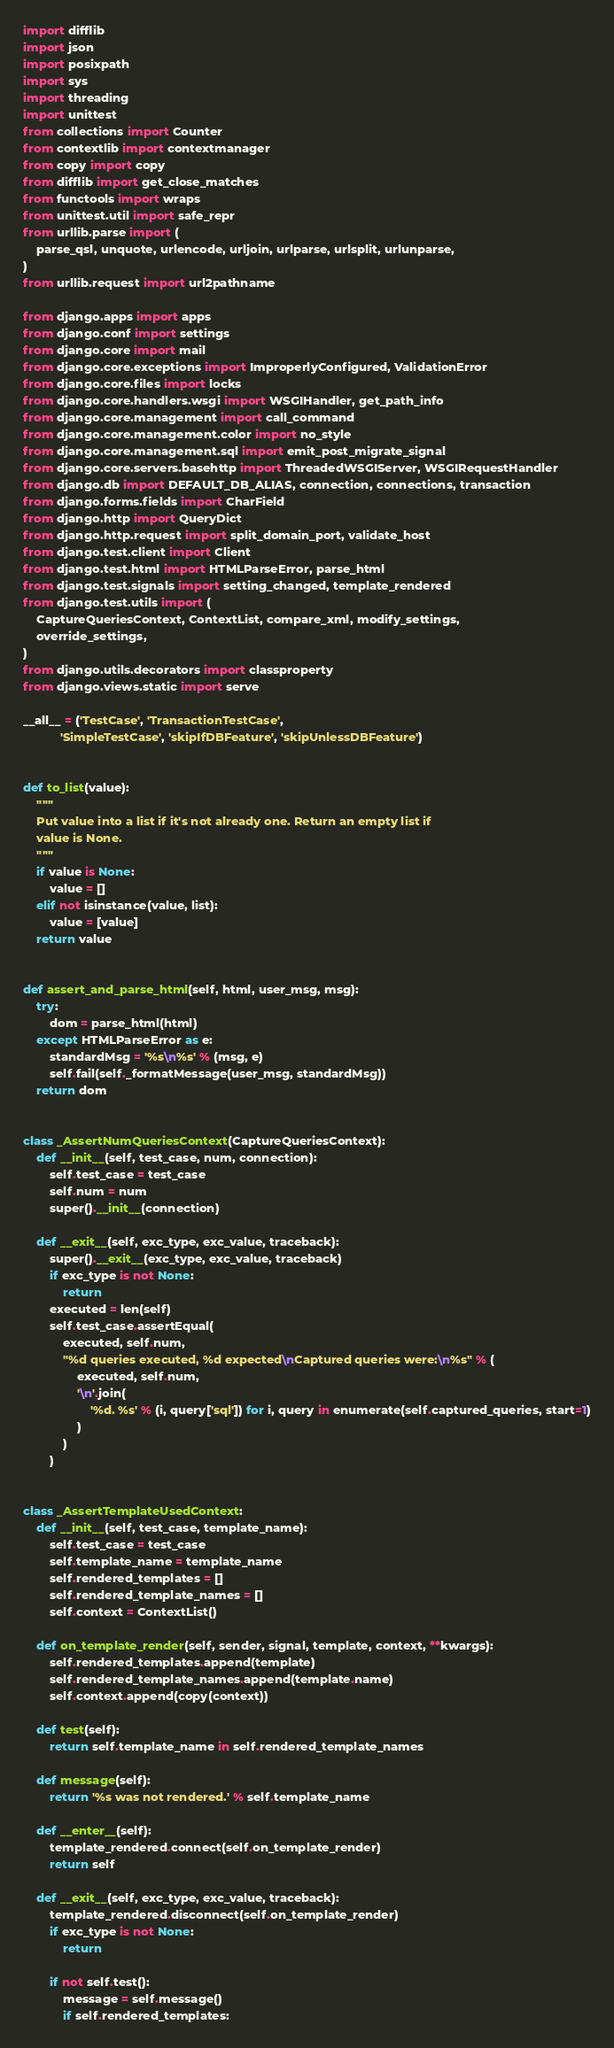<code> <loc_0><loc_0><loc_500><loc_500><_Python_>import difflib
import json
import posixpath
import sys
import threading
import unittest
from collections import Counter
from contextlib import contextmanager
from copy import copy
from difflib import get_close_matches
from functools import wraps
from unittest.util import safe_repr
from urllib.parse import (
    parse_qsl, unquote, urlencode, urljoin, urlparse, urlsplit, urlunparse,
)
from urllib.request import url2pathname

from django.apps import apps
from django.conf import settings
from django.core import mail
from django.core.exceptions import ImproperlyConfigured, ValidationError
from django.core.files import locks
from django.core.handlers.wsgi import WSGIHandler, get_path_info
from django.core.management import call_command
from django.core.management.color import no_style
from django.core.management.sql import emit_post_migrate_signal
from django.core.servers.basehttp import ThreadedWSGIServer, WSGIRequestHandler
from django.db import DEFAULT_DB_ALIAS, connection, connections, transaction
from django.forms.fields import CharField
from django.http import QueryDict
from django.http.request import split_domain_port, validate_host
from django.test.client import Client
from django.test.html import HTMLParseError, parse_html
from django.test.signals import setting_changed, template_rendered
from django.test.utils import (
    CaptureQueriesContext, ContextList, compare_xml, modify_settings,
    override_settings,
)
from django.utils.decorators import classproperty
from django.views.static import serve

__all__ = ('TestCase', 'TransactionTestCase',
           'SimpleTestCase', 'skipIfDBFeature', 'skipUnlessDBFeature')


def to_list(value):
    """
    Put value into a list if it's not already one. Return an empty list if
    value is None.
    """
    if value is None:
        value = []
    elif not isinstance(value, list):
        value = [value]
    return value


def assert_and_parse_html(self, html, user_msg, msg):
    try:
        dom = parse_html(html)
    except HTMLParseError as e:
        standardMsg = '%s\n%s' % (msg, e)
        self.fail(self._formatMessage(user_msg, standardMsg))
    return dom


class _AssertNumQueriesContext(CaptureQueriesContext):
    def __init__(self, test_case, num, connection):
        self.test_case = test_case
        self.num = num
        super().__init__(connection)

    def __exit__(self, exc_type, exc_value, traceback):
        super().__exit__(exc_type, exc_value, traceback)
        if exc_type is not None:
            return
        executed = len(self)
        self.test_case.assertEqual(
            executed, self.num,
            "%d queries executed, %d expected\nCaptured queries were:\n%s" % (
                executed, self.num,
                '\n'.join(
                    '%d. %s' % (i, query['sql']) for i, query in enumerate(self.captured_queries, start=1)
                )
            )
        )


class _AssertTemplateUsedContext:
    def __init__(self, test_case, template_name):
        self.test_case = test_case
        self.template_name = template_name
        self.rendered_templates = []
        self.rendered_template_names = []
        self.context = ContextList()

    def on_template_render(self, sender, signal, template, context, **kwargs):
        self.rendered_templates.append(template)
        self.rendered_template_names.append(template.name)
        self.context.append(copy(context))

    def test(self):
        return self.template_name in self.rendered_template_names

    def message(self):
        return '%s was not rendered.' % self.template_name

    def __enter__(self):
        template_rendered.connect(self.on_template_render)
        return self

    def __exit__(self, exc_type, exc_value, traceback):
        template_rendered.disconnect(self.on_template_render)
        if exc_type is not None:
            return

        if not self.test():
            message = self.message()
            if self.rendered_templates:</code> 